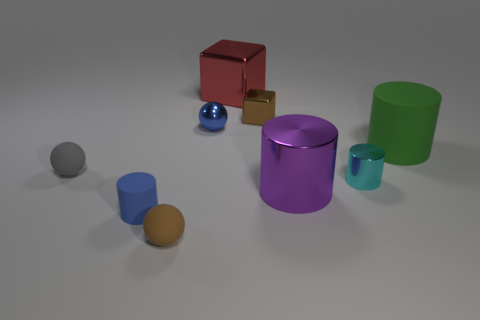How might the presence of these objects affect the room's ambiance? These objects, with their varied shapes and colors, contribute to a playful and creative atmosphere. Their simple geometric forms and bold colors could also inspire a minimalist or contemporary vibe in the room. 